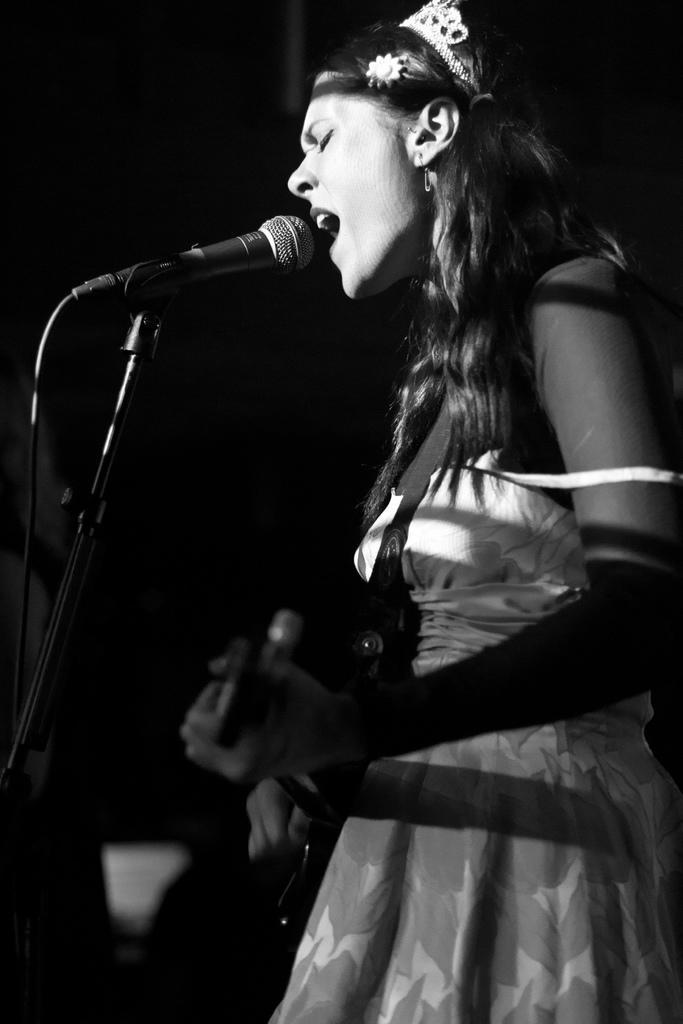Can you describe this image briefly? In the picture we can see a black and white image of a woman standing and singing a song in the microphone which is to the stand and beside her we can see dark. 